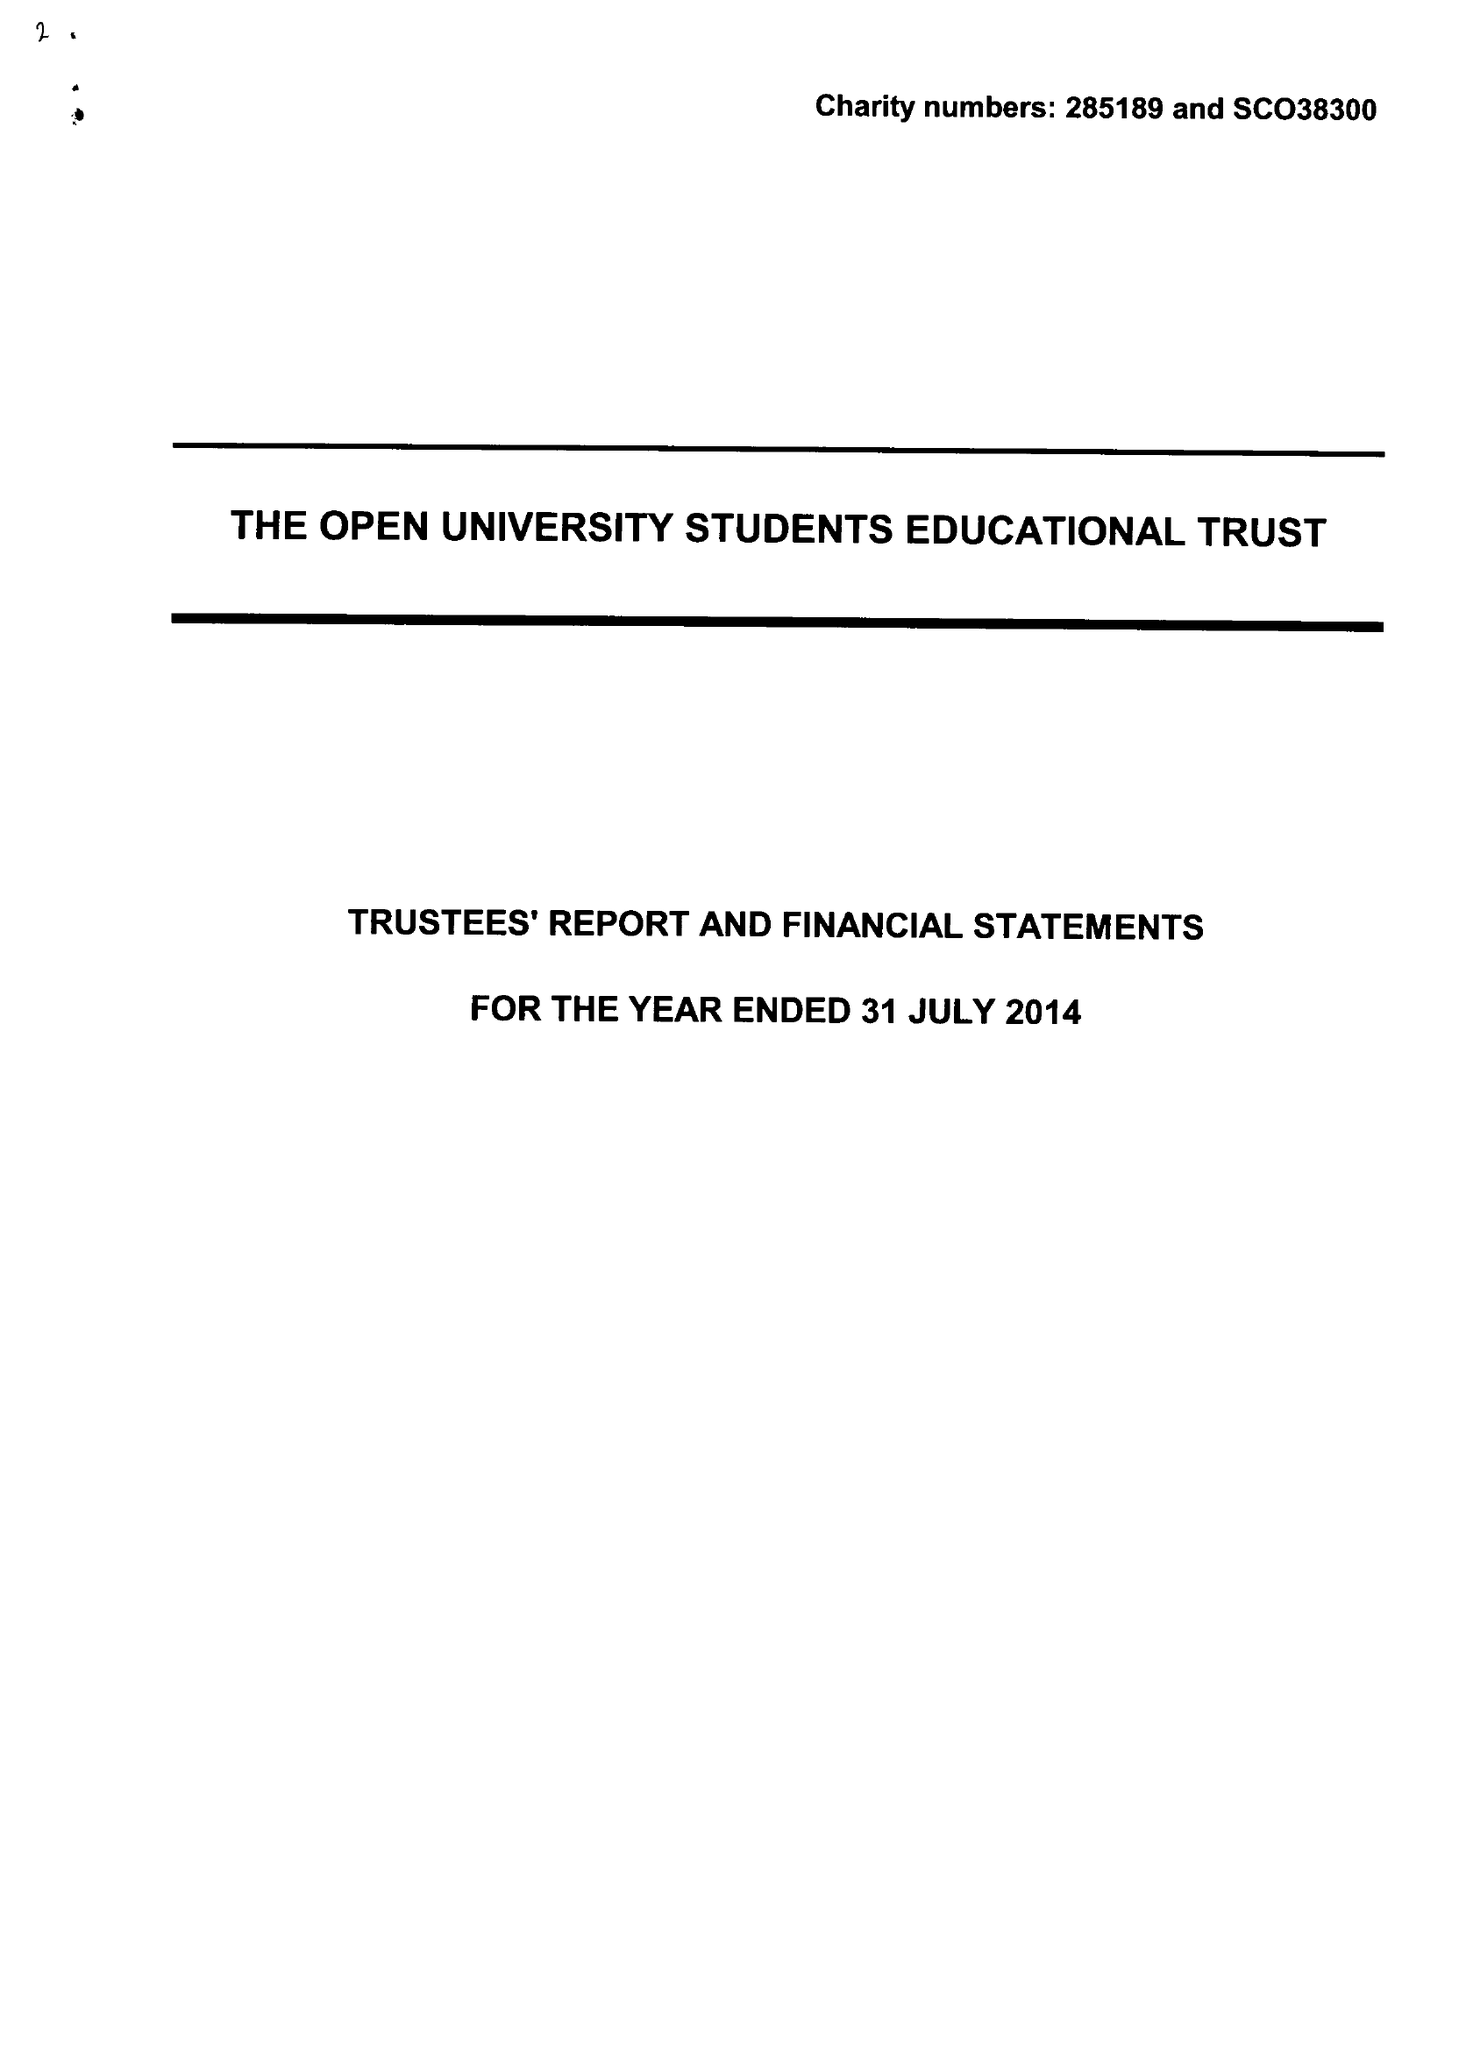What is the value for the address__street_line?
Answer the question using a single word or phrase. PO BOX 397 